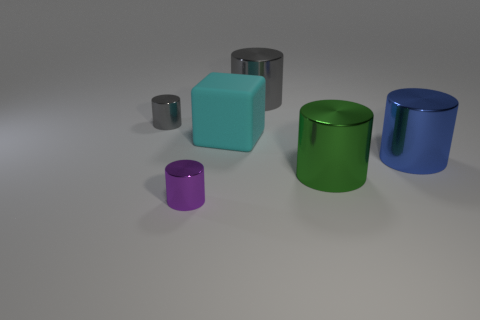How many small purple cylinders are behind the gray metal thing in front of the large cylinder that is behind the tiny gray metal cylinder? 0 